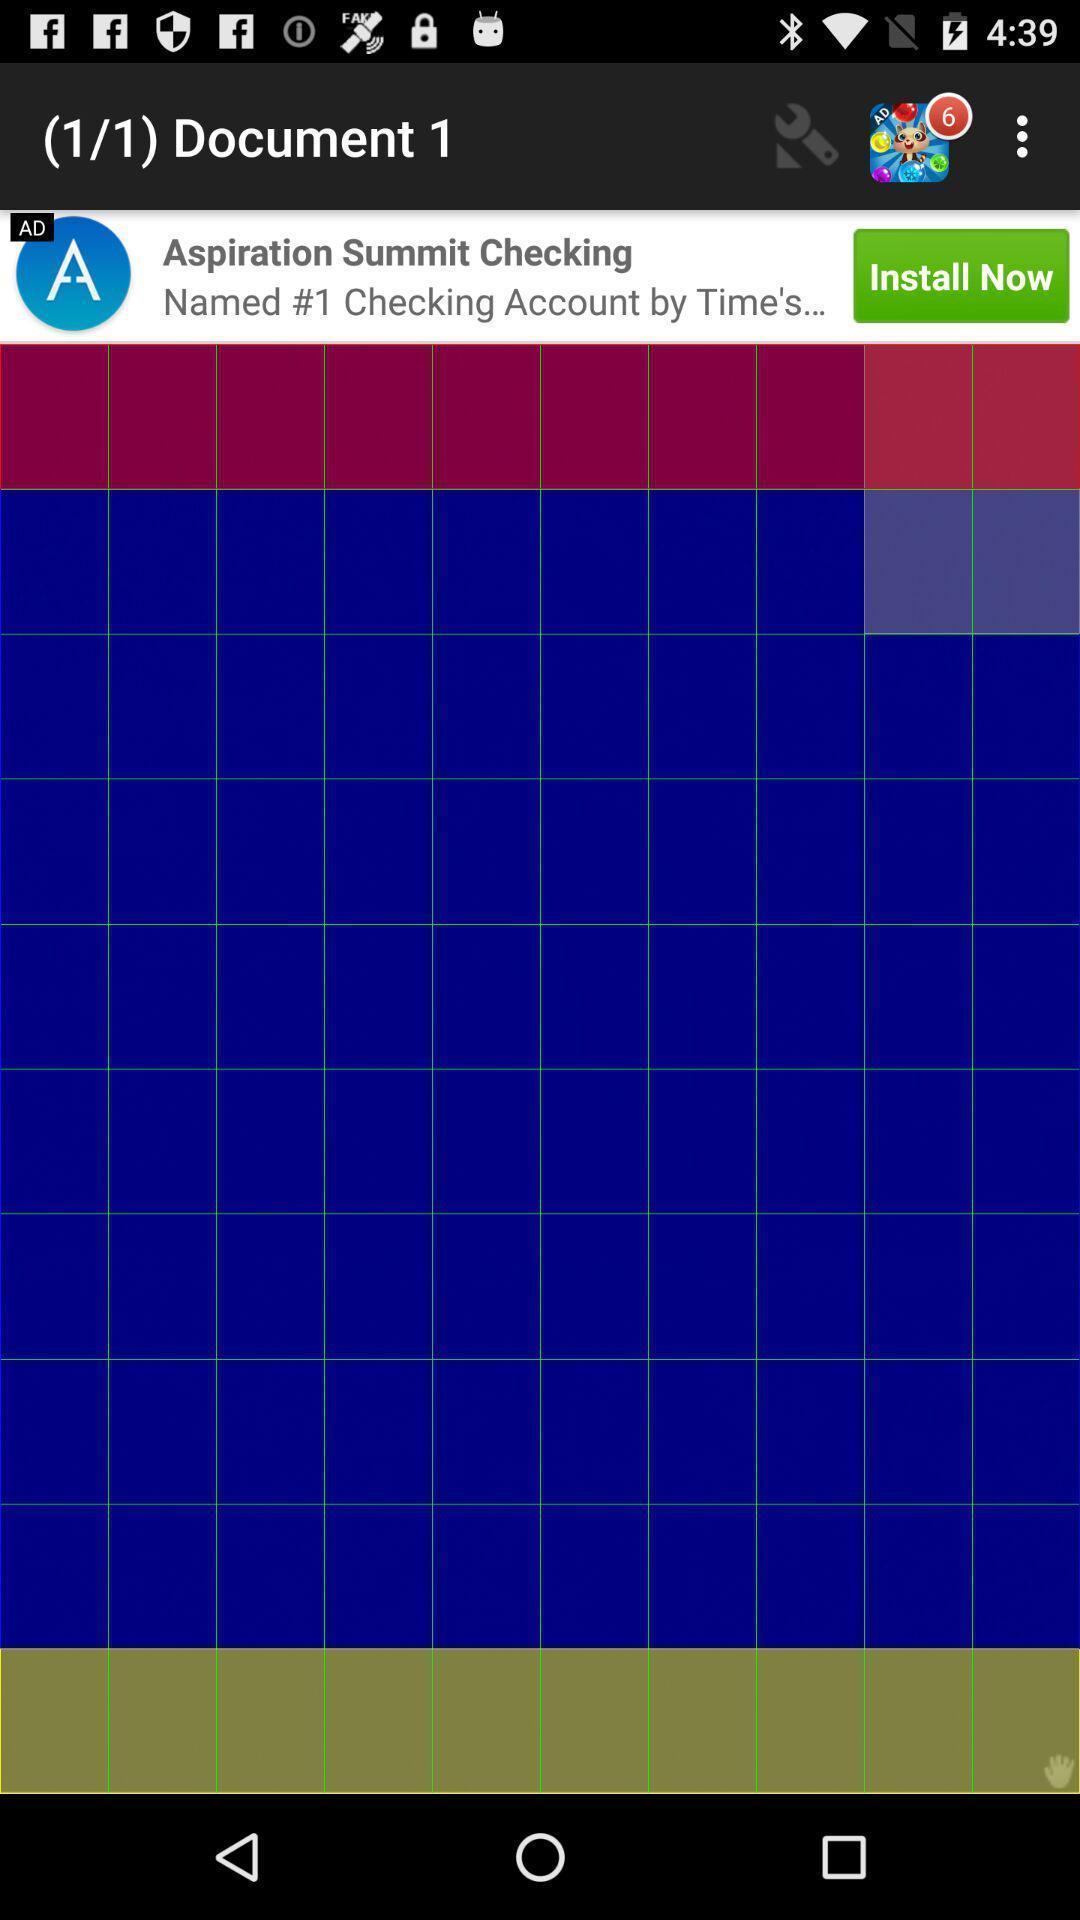Give me a summary of this screen capture. Page displaying the documents. 